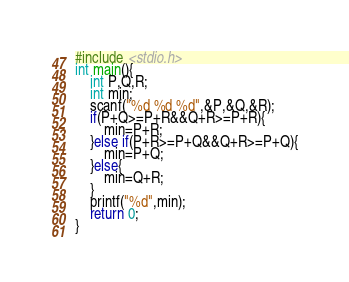Convert code to text. <code><loc_0><loc_0><loc_500><loc_500><_C_>#include <stdio.h>
int main(){
	int P,Q,R;
	int min; 
	scanf("%d %d %d",&P,&Q,&R);
	if(P+Q>=P+R&&Q+R>=P+R){
		min=P+R;
	}else if(P+R>=P+Q&&Q+R>=P+Q){
		min=P+Q;
	}else{
		min=Q+R;
	}	
	printf("%d",min);
	return 0;
}</code> 